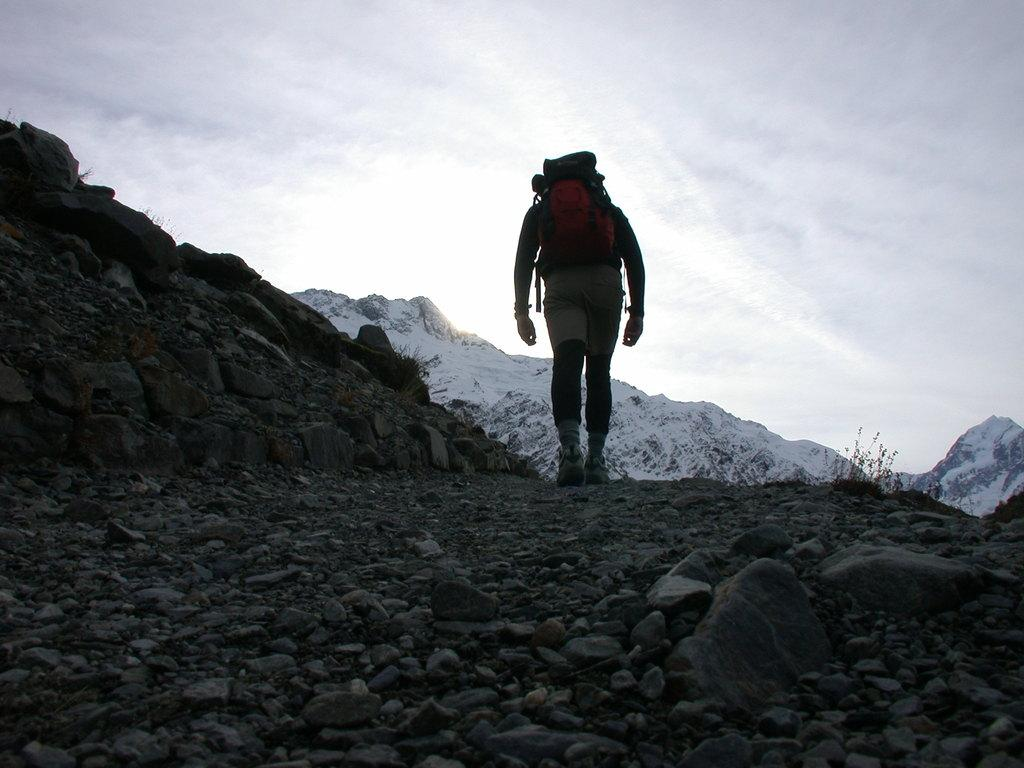What is the person in the image doing? There is a person walking in the image. What is the person carrying while walking? The person is carrying a work bag. What type of terrain can be seen in the image? There are stones visible in the image. What can be seen in the background of the image? There is a hill covered with snow and the sky visible in the background of the image. How many cows are grazing in the square in the image? There are no cows or squares present in the image. 